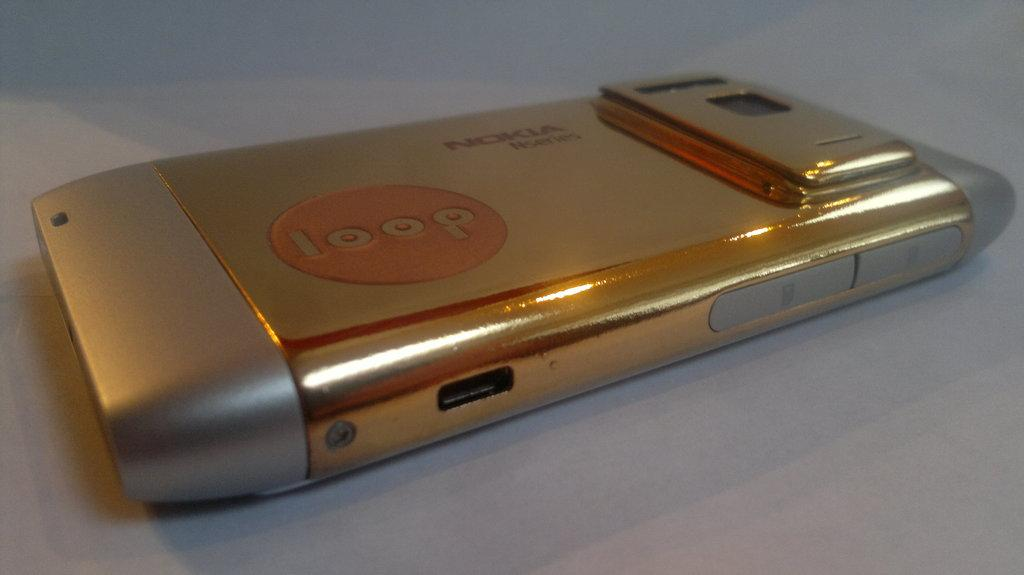<image>
Describe the image concisely. A Nokia camera that says loop on the front 